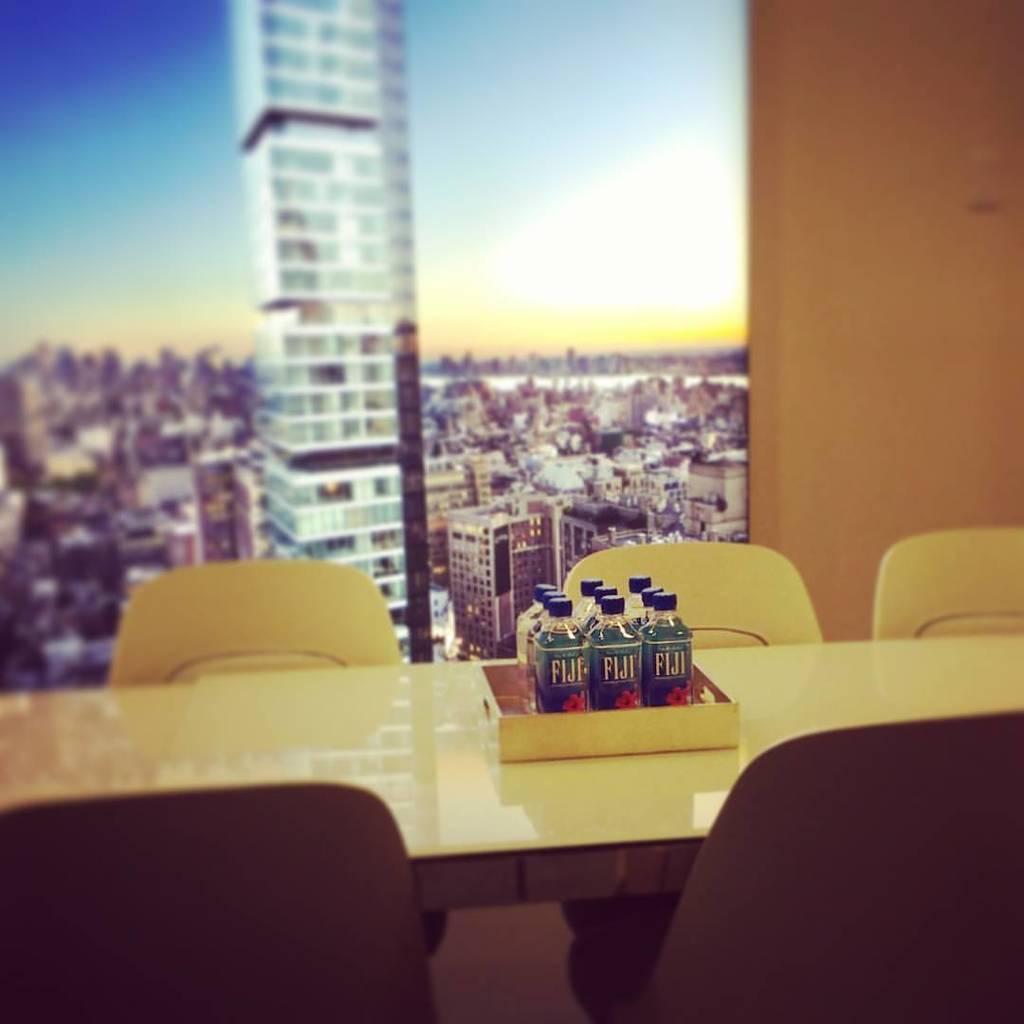Please provide a concise description of this image. The image is inside the room. In the image there is a table, on table we can see few water bottles and we can also see five chairs. In background there is a wall and buildings and sky is on top. 